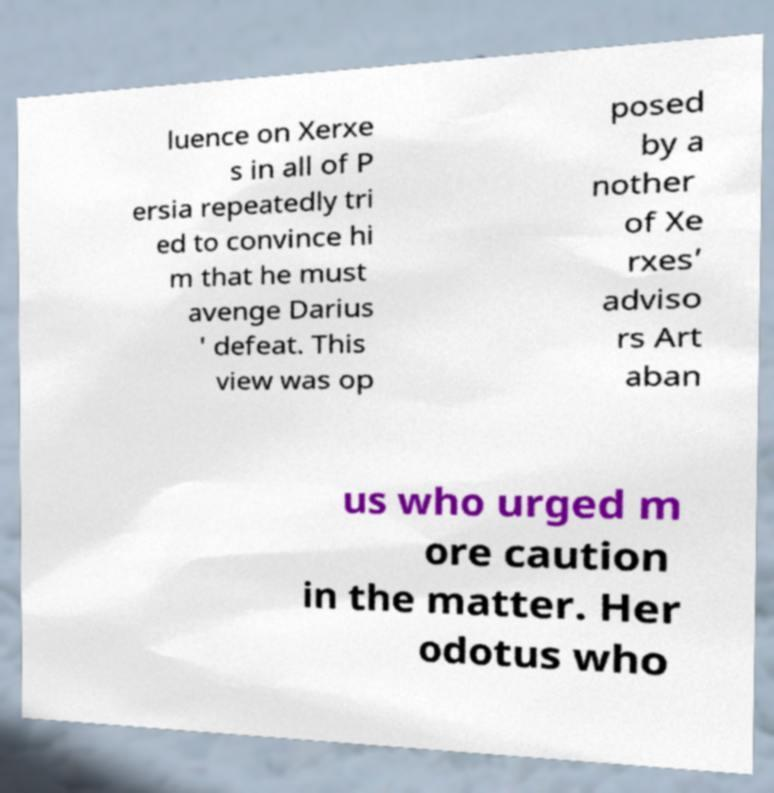There's text embedded in this image that I need extracted. Can you transcribe it verbatim? luence on Xerxe s in all of P ersia repeatedly tri ed to convince hi m that he must avenge Darius ' defeat. This view was op posed by a nother of Xe rxes’ adviso rs Art aban us who urged m ore caution in the matter. Her odotus who 